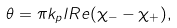<formula> <loc_0><loc_0><loc_500><loc_500>\theta = \pi k _ { p } l R e ( \chi _ { - } - \chi _ { + } ) ,</formula> 